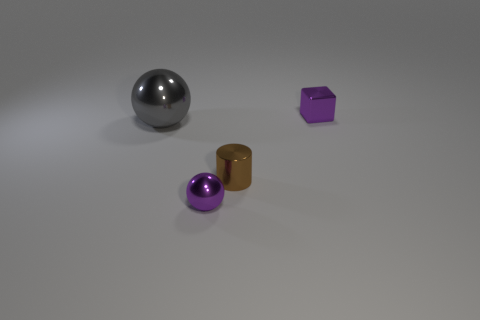Add 2 purple metal cylinders. How many objects exist? 6 Subtract all cylinders. How many objects are left? 3 Add 4 tiny purple metallic cubes. How many tiny purple metallic cubes are left? 5 Add 2 small brown cubes. How many small brown cubes exist? 2 Subtract 0 green spheres. How many objects are left? 4 Subtract all big rubber balls. Subtract all tiny brown cylinders. How many objects are left? 3 